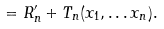Convert formula to latex. <formula><loc_0><loc_0><loc_500><loc_500>= R ^ { \prime } _ { n } + T _ { n } ( x _ { 1 } , \dots x _ { n } ) .</formula> 